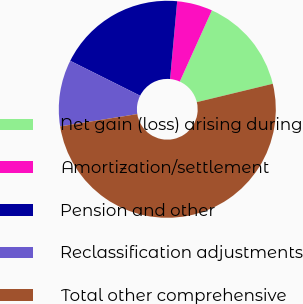Convert chart to OTSL. <chart><loc_0><loc_0><loc_500><loc_500><pie_chart><fcel>Net gain (loss) arising during<fcel>Amortization/settlement<fcel>Pension and other<fcel>Reclassification adjustments<fcel>Total other comprehensive<nl><fcel>14.48%<fcel>5.29%<fcel>19.08%<fcel>9.89%<fcel>51.26%<nl></chart> 